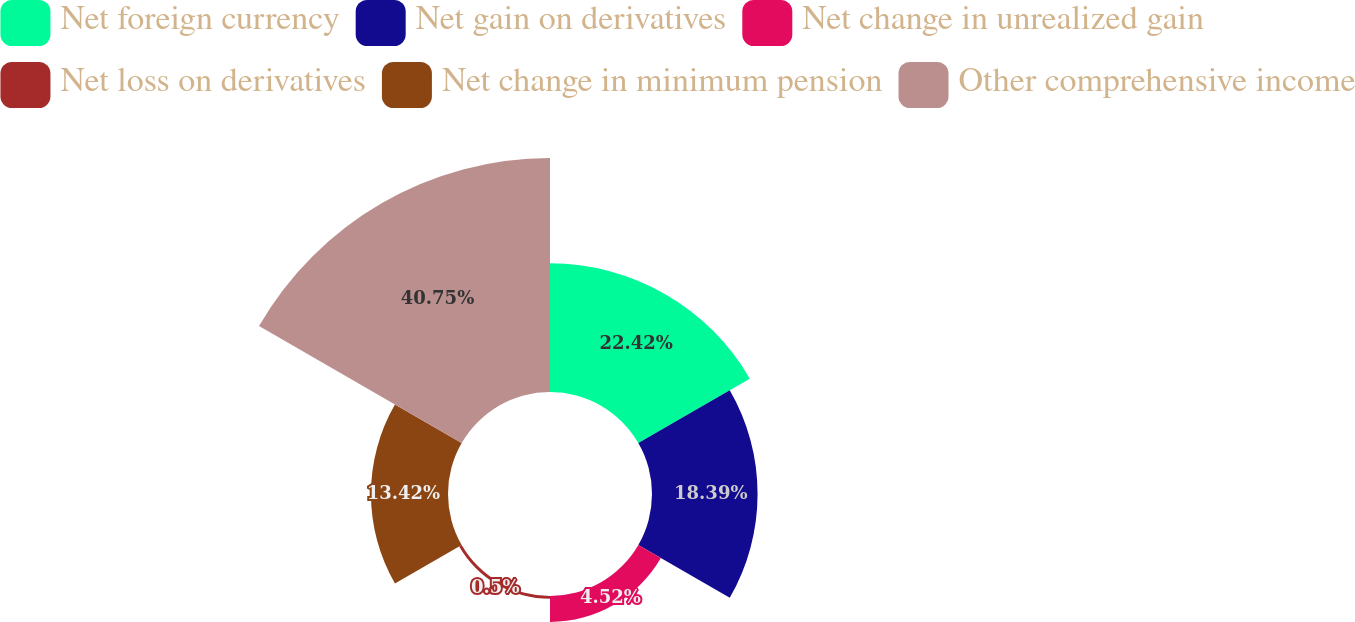<chart> <loc_0><loc_0><loc_500><loc_500><pie_chart><fcel>Net foreign currency<fcel>Net gain on derivatives<fcel>Net change in unrealized gain<fcel>Net loss on derivatives<fcel>Net change in minimum pension<fcel>Other comprehensive income<nl><fcel>22.42%<fcel>18.39%<fcel>4.52%<fcel>0.5%<fcel>13.42%<fcel>40.76%<nl></chart> 